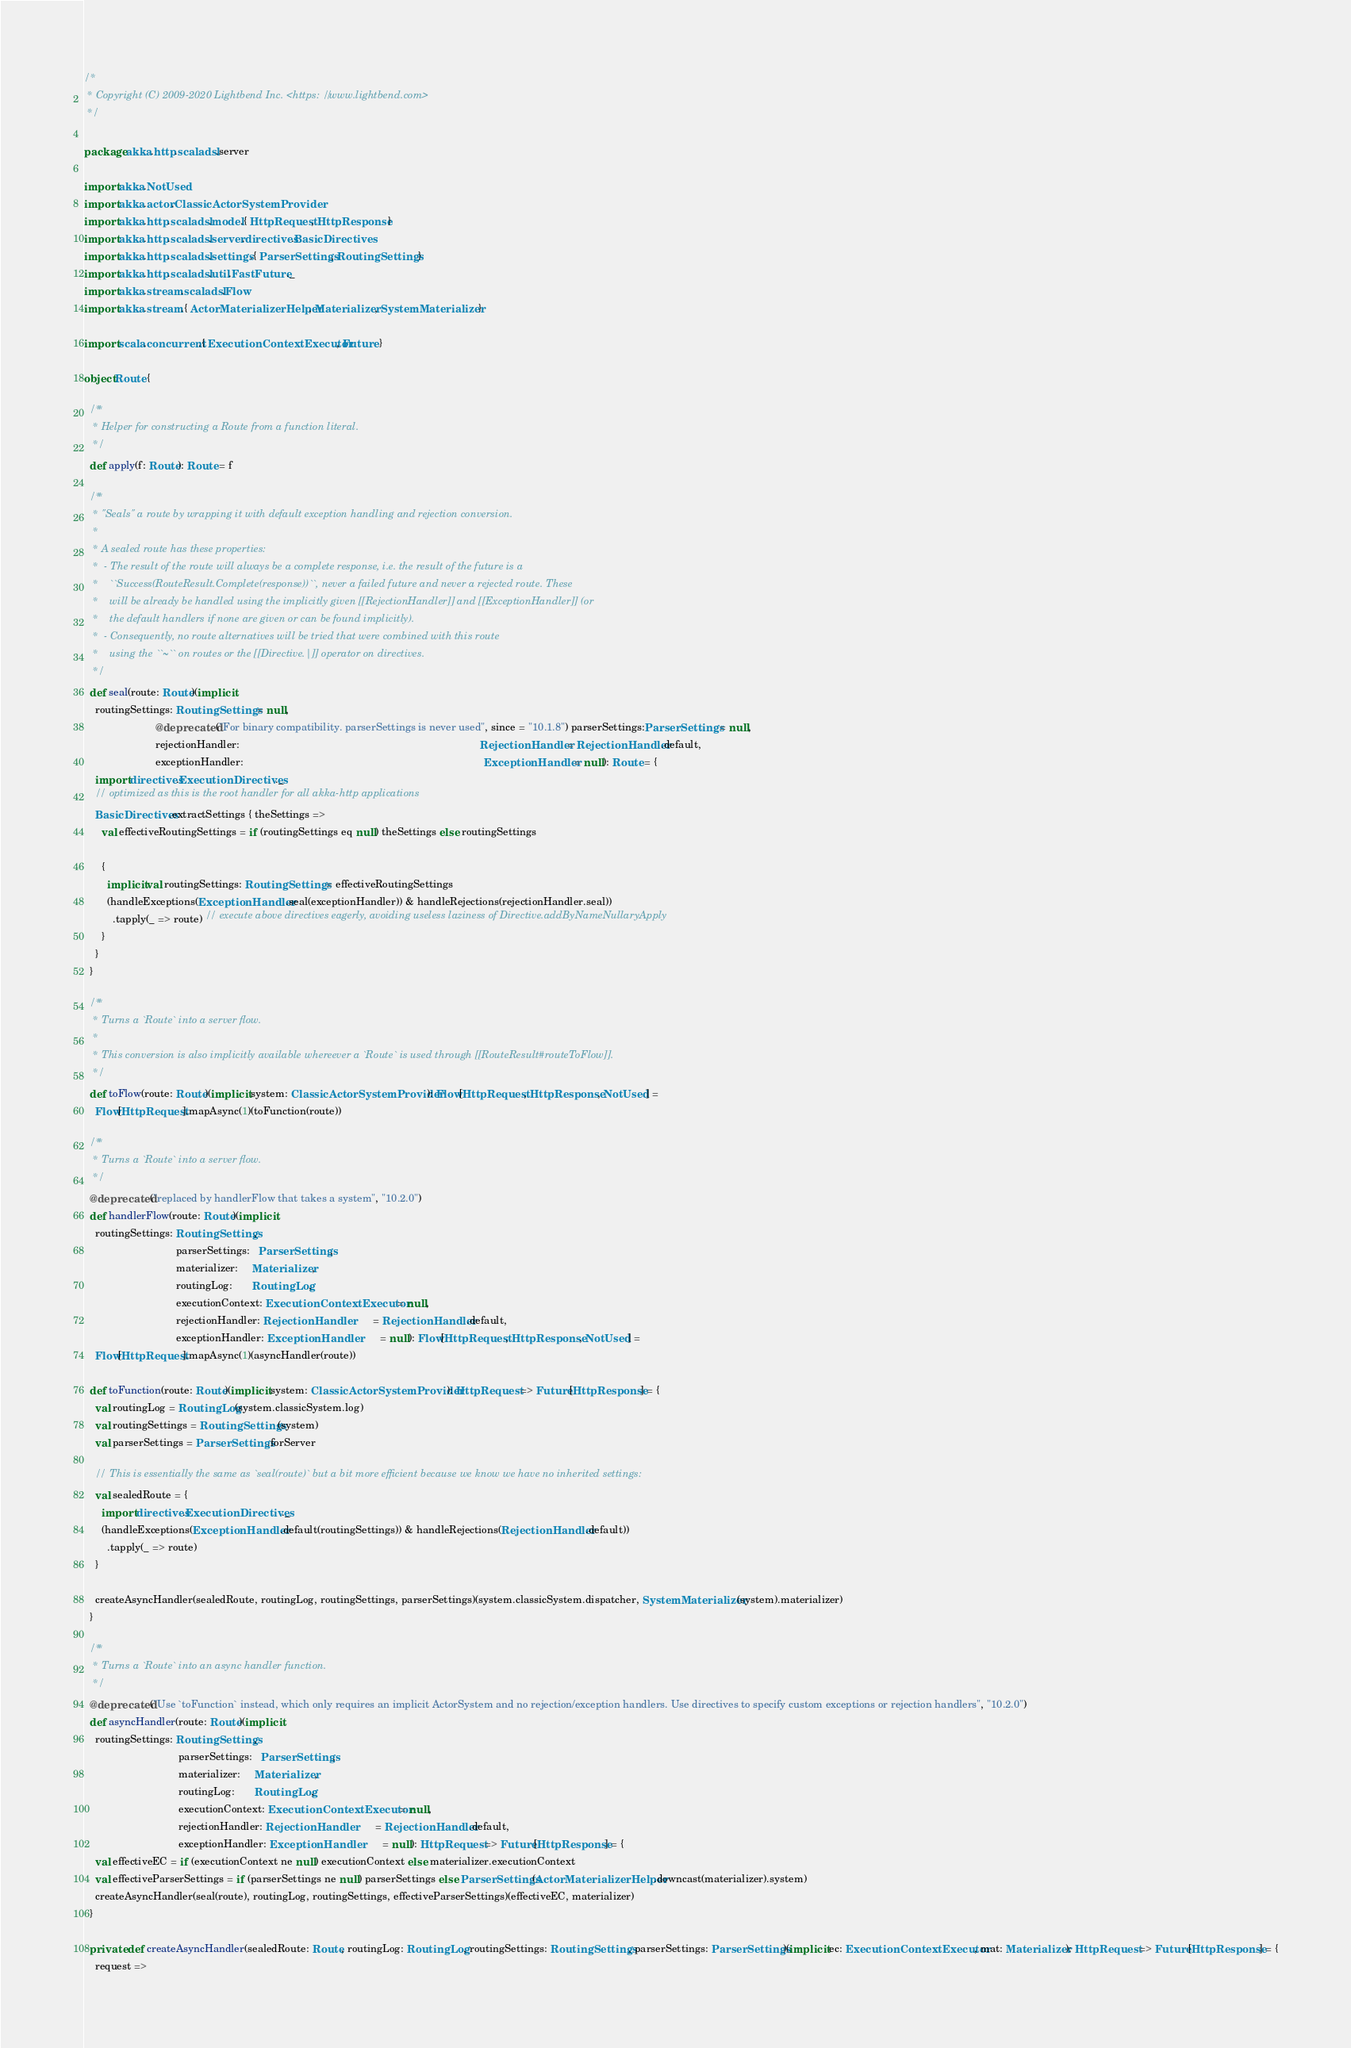Convert code to text. <code><loc_0><loc_0><loc_500><loc_500><_Scala_>/*
 * Copyright (C) 2009-2020 Lightbend Inc. <https://www.lightbend.com>
 */

package akka.http.scaladsl.server

import akka.NotUsed
import akka.actor.ClassicActorSystemProvider
import akka.http.scaladsl.model.{ HttpRequest, HttpResponse }
import akka.http.scaladsl.server.directives.BasicDirectives
import akka.http.scaladsl.settings.{ ParserSettings, RoutingSettings }
import akka.http.scaladsl.util.FastFuture._
import akka.stream.scaladsl.Flow
import akka.stream.{ ActorMaterializerHelper, Materializer, SystemMaterializer }

import scala.concurrent.{ ExecutionContextExecutor, Future }

object Route {

  /**
   * Helper for constructing a Route from a function literal.
   */
  def apply(f: Route): Route = f

  /**
   * "Seals" a route by wrapping it with default exception handling and rejection conversion.
   *
   * A sealed route has these properties:
   *  - The result of the route will always be a complete response, i.e. the result of the future is a
   *    ``Success(RouteResult.Complete(response))``, never a failed future and never a rejected route. These
   *    will be already be handled using the implicitly given [[RejectionHandler]] and [[ExceptionHandler]] (or
   *    the default handlers if none are given or can be found implicitly).
   *  - Consequently, no route alternatives will be tried that were combined with this route
   *    using the ``~`` on routes or the [[Directive.|]] operator on directives.
   */
  def seal(route: Route)(implicit
    routingSettings: RoutingSettings = null,
                         @deprecated("For binary compatibility. parserSettings is never used", since = "10.1.8") parserSettings:ParserSettings = null,
                         rejectionHandler:                                                                                    RejectionHandler = RejectionHandler.default,
                         exceptionHandler:                                                                                    ExceptionHandler = null): Route = {
    import directives.ExecutionDirectives._
    // optimized as this is the root handler for all akka-http applications
    BasicDirectives.extractSettings { theSettings =>
      val effectiveRoutingSettings = if (routingSettings eq null) theSettings else routingSettings

      {
        implicit val routingSettings: RoutingSettings = effectiveRoutingSettings
        (handleExceptions(ExceptionHandler.seal(exceptionHandler)) & handleRejections(rejectionHandler.seal))
          .tapply(_ => route) // execute above directives eagerly, avoiding useless laziness of Directive.addByNameNullaryApply
      }
    }
  }

  /**
   * Turns a `Route` into a server flow.
   *
   * This conversion is also implicitly available whereever a `Route` is used through [[RouteResult#routeToFlow]].
   */
  def toFlow(route: Route)(implicit system: ClassicActorSystemProvider): Flow[HttpRequest, HttpResponse, NotUsed] =
    Flow[HttpRequest].mapAsync(1)(toFunction(route))

  /**
   * Turns a `Route` into a server flow.
   */
  @deprecated("replaced by handlerFlow that takes a system", "10.2.0")
  def handlerFlow(route: Route)(implicit
    routingSettings: RoutingSettings,
                                parserSettings:   ParserSettings,
                                materializer:     Materializer,
                                routingLog:       RoutingLog,
                                executionContext: ExecutionContextExecutor = null,
                                rejectionHandler: RejectionHandler         = RejectionHandler.default,
                                exceptionHandler: ExceptionHandler         = null): Flow[HttpRequest, HttpResponse, NotUsed] =
    Flow[HttpRequest].mapAsync(1)(asyncHandler(route))

  def toFunction(route: Route)(implicit system: ClassicActorSystemProvider): HttpRequest => Future[HttpResponse] = {
    val routingLog = RoutingLog(system.classicSystem.log)
    val routingSettings = RoutingSettings(system)
    val parserSettings = ParserSettings.forServer

    // This is essentially the same as `seal(route)` but a bit more efficient because we know we have no inherited settings:
    val sealedRoute = {
      import directives.ExecutionDirectives._
      (handleExceptions(ExceptionHandler.default(routingSettings)) & handleRejections(RejectionHandler.default))
        .tapply(_ => route)
    }

    createAsyncHandler(sealedRoute, routingLog, routingSettings, parserSettings)(system.classicSystem.dispatcher, SystemMaterializer(system).materializer)
  }

  /**
   * Turns a `Route` into an async handler function.
   */
  @deprecated("Use `toFunction` instead, which only requires an implicit ActorSystem and no rejection/exception handlers. Use directives to specify custom exceptions or rejection handlers", "10.2.0")
  def asyncHandler(route: Route)(implicit
    routingSettings: RoutingSettings,
                                 parserSettings:   ParserSettings,
                                 materializer:     Materializer,
                                 routingLog:       RoutingLog,
                                 executionContext: ExecutionContextExecutor = null,
                                 rejectionHandler: RejectionHandler         = RejectionHandler.default,
                                 exceptionHandler: ExceptionHandler         = null): HttpRequest => Future[HttpResponse] = {
    val effectiveEC = if (executionContext ne null) executionContext else materializer.executionContext
    val effectiveParserSettings = if (parserSettings ne null) parserSettings else ParserSettings(ActorMaterializerHelper.downcast(materializer).system)
    createAsyncHandler(seal(route), routingLog, routingSettings, effectiveParserSettings)(effectiveEC, materializer)
  }

  private def createAsyncHandler(sealedRoute: Route, routingLog: RoutingLog, routingSettings: RoutingSettings, parserSettings: ParserSettings)(implicit ec: ExecutionContextExecutor, mat: Materializer): HttpRequest => Future[HttpResponse] = {
    request =></code> 